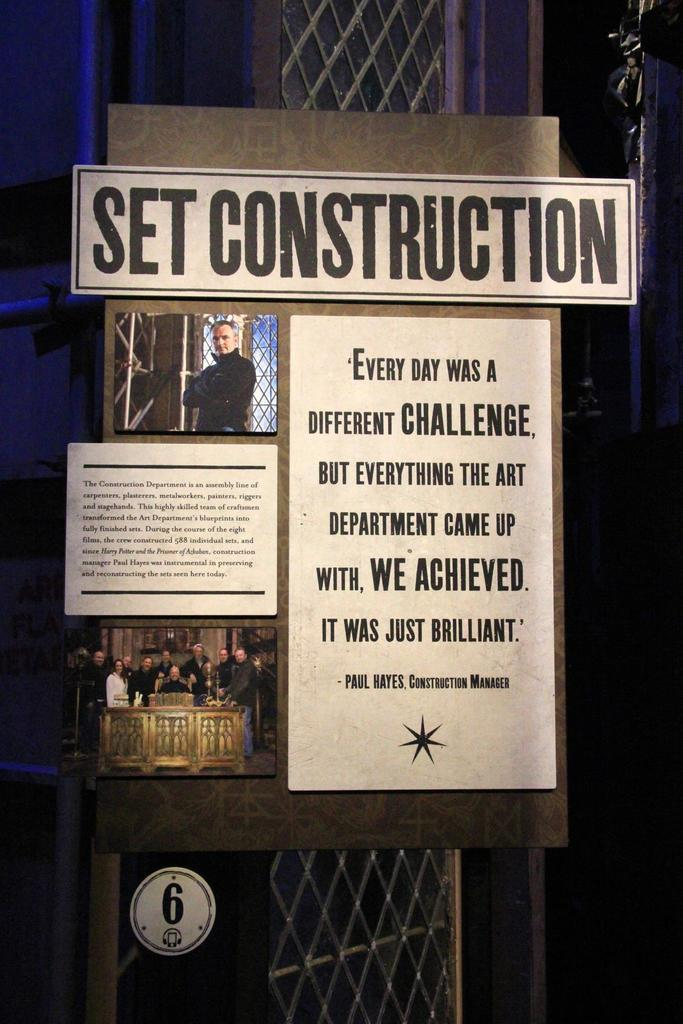What is the main object in the picture? There is a board in the picture. What can be seen on the board? The board has photos of people on it and there is writing on the board. Can you describe the background of the picture? There are objects visible in the background of the picture. What type of plant is growing in the channel in the image? There is no channel or plant present in the image. 